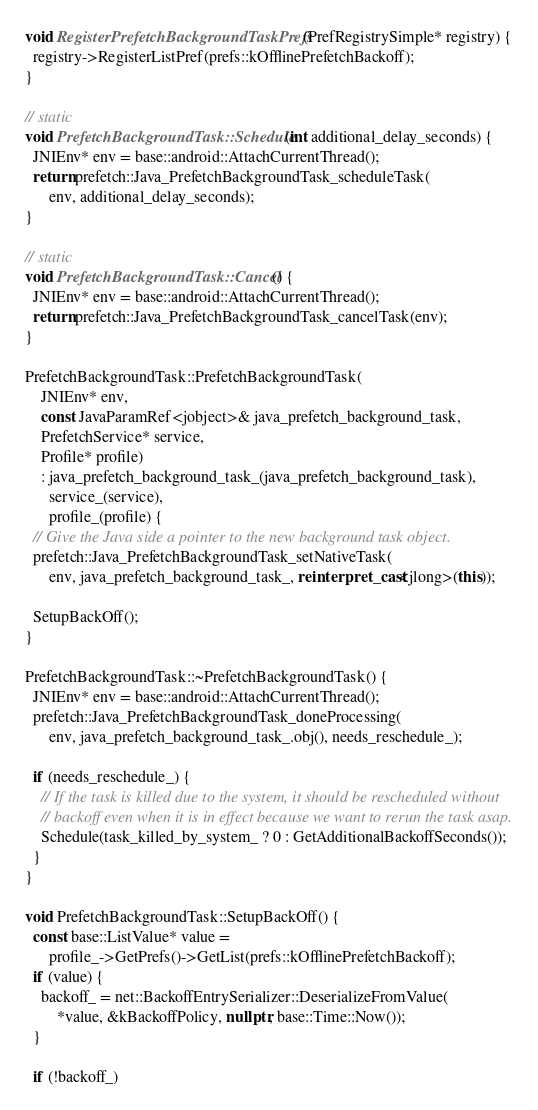Convert code to text. <code><loc_0><loc_0><loc_500><loc_500><_C++_>
void RegisterPrefetchBackgroundTaskPrefs(PrefRegistrySimple* registry) {
  registry->RegisterListPref(prefs::kOfflinePrefetchBackoff);
}

// static
void PrefetchBackgroundTask::Schedule(int additional_delay_seconds) {
  JNIEnv* env = base::android::AttachCurrentThread();
  return prefetch::Java_PrefetchBackgroundTask_scheduleTask(
      env, additional_delay_seconds);
}

// static
void PrefetchBackgroundTask::Cancel() {
  JNIEnv* env = base::android::AttachCurrentThread();
  return prefetch::Java_PrefetchBackgroundTask_cancelTask(env);
}

PrefetchBackgroundTask::PrefetchBackgroundTask(
    JNIEnv* env,
    const JavaParamRef<jobject>& java_prefetch_background_task,
    PrefetchService* service,
    Profile* profile)
    : java_prefetch_background_task_(java_prefetch_background_task),
      service_(service),
      profile_(profile) {
  // Give the Java side a pointer to the new background task object.
  prefetch::Java_PrefetchBackgroundTask_setNativeTask(
      env, java_prefetch_background_task_, reinterpret_cast<jlong>(this));

  SetupBackOff();
}

PrefetchBackgroundTask::~PrefetchBackgroundTask() {
  JNIEnv* env = base::android::AttachCurrentThread();
  prefetch::Java_PrefetchBackgroundTask_doneProcessing(
      env, java_prefetch_background_task_.obj(), needs_reschedule_);

  if (needs_reschedule_) {
    // If the task is killed due to the system, it should be rescheduled without
    // backoff even when it is in effect because we want to rerun the task asap.
    Schedule(task_killed_by_system_ ? 0 : GetAdditionalBackoffSeconds());
  }
}

void PrefetchBackgroundTask::SetupBackOff() {
  const base::ListValue* value =
      profile_->GetPrefs()->GetList(prefs::kOfflinePrefetchBackoff);
  if (value) {
    backoff_ = net::BackoffEntrySerializer::DeserializeFromValue(
        *value, &kBackoffPolicy, nullptr, base::Time::Now());
  }

  if (!backoff_)</code> 